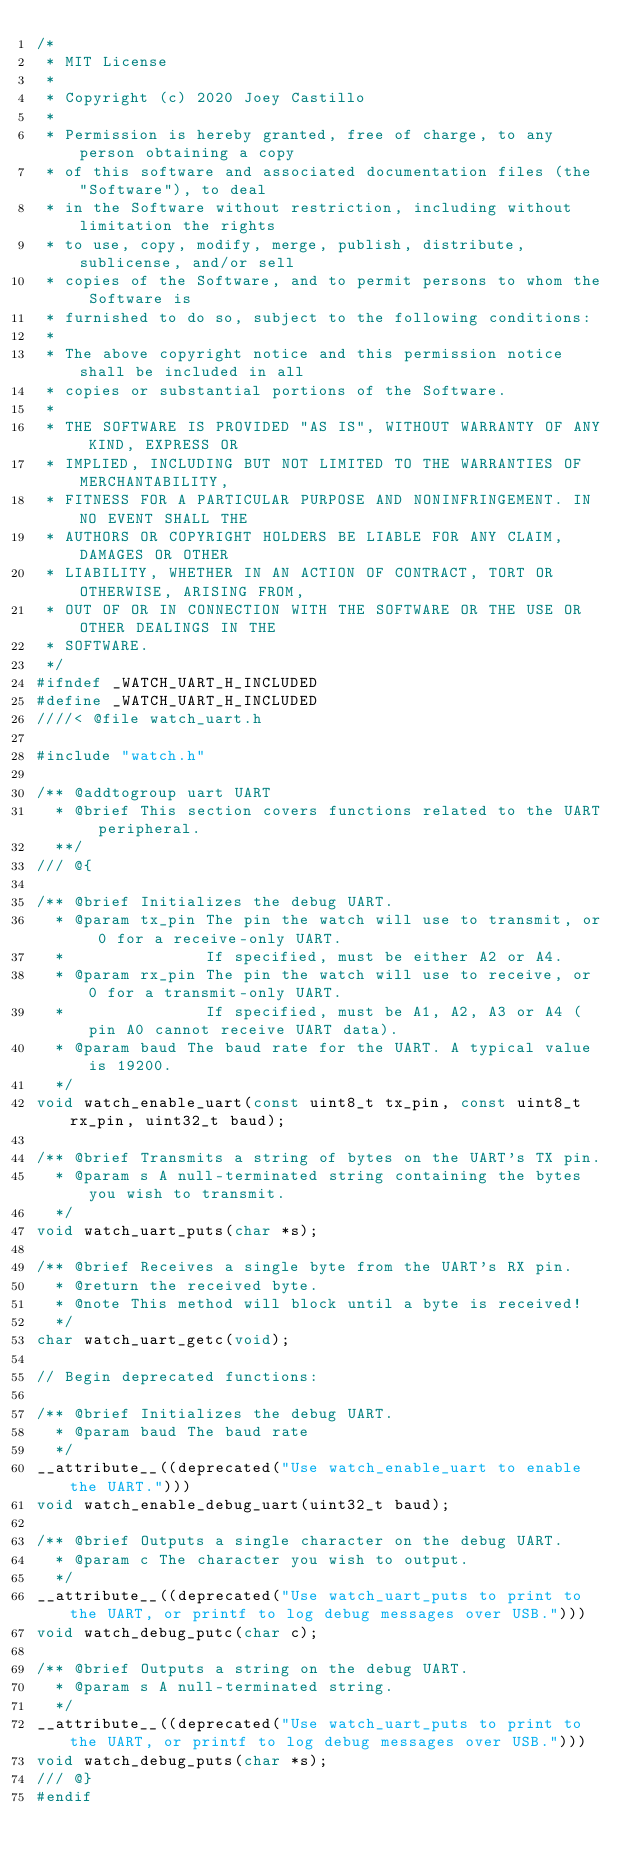Convert code to text. <code><loc_0><loc_0><loc_500><loc_500><_C_>/*
 * MIT License
 *
 * Copyright (c) 2020 Joey Castillo
 *
 * Permission is hereby granted, free of charge, to any person obtaining a copy
 * of this software and associated documentation files (the "Software"), to deal
 * in the Software without restriction, including without limitation the rights
 * to use, copy, modify, merge, publish, distribute, sublicense, and/or sell
 * copies of the Software, and to permit persons to whom the Software is
 * furnished to do so, subject to the following conditions:
 *
 * The above copyright notice and this permission notice shall be included in all
 * copies or substantial portions of the Software.
 *
 * THE SOFTWARE IS PROVIDED "AS IS", WITHOUT WARRANTY OF ANY KIND, EXPRESS OR
 * IMPLIED, INCLUDING BUT NOT LIMITED TO THE WARRANTIES OF MERCHANTABILITY,
 * FITNESS FOR A PARTICULAR PURPOSE AND NONINFRINGEMENT. IN NO EVENT SHALL THE
 * AUTHORS OR COPYRIGHT HOLDERS BE LIABLE FOR ANY CLAIM, DAMAGES OR OTHER
 * LIABILITY, WHETHER IN AN ACTION OF CONTRACT, TORT OR OTHERWISE, ARISING FROM,
 * OUT OF OR IN CONNECTION WITH THE SOFTWARE OR THE USE OR OTHER DEALINGS IN THE
 * SOFTWARE.
 */
#ifndef _WATCH_UART_H_INCLUDED
#define _WATCH_UART_H_INCLUDED
////< @file watch_uart.h

#include "watch.h"

/** @addtogroup uart UART
  * @brief This section covers functions related to the UART peripheral.
  **/
/// @{

/** @brief Initializes the debug UART.
  * @param tx_pin The pin the watch will use to transmit, or 0 for a receive-only UART.
  *               If specified, must be either A2 or A4.
  * @param rx_pin The pin the watch will use to receive, or 0 for a transmit-only UART.
  *               If specified, must be A1, A2, A3 or A4 (pin A0 cannot receive UART data).
  * @param baud The baud rate for the UART. A typical value is 19200.
  */
void watch_enable_uart(const uint8_t tx_pin, const uint8_t rx_pin, uint32_t baud);

/** @brief Transmits a string of bytes on the UART's TX pin.
  * @param s A null-terminated string containing the bytes you wish to transmit.
  */
void watch_uart_puts(char *s);

/** @brief Receives a single byte from the UART's RX pin.
  * @return the received byte.
  * @note This method will block until a byte is received!
  */
char watch_uart_getc(void);

// Begin deprecated functions:

/** @brief Initializes the debug UART.
  * @param baud The baud rate
  */
__attribute__((deprecated("Use watch_enable_uart to enable the UART.")))
void watch_enable_debug_uart(uint32_t baud);

/** @brief Outputs a single character on the debug UART.
  * @param c The character you wish to output.
  */
__attribute__((deprecated("Use watch_uart_puts to print to the UART, or printf to log debug messages over USB.")))
void watch_debug_putc(char c);

/** @brief Outputs a string on the debug UART.
  * @param s A null-terminated string.
  */
__attribute__((deprecated("Use watch_uart_puts to print to the UART, or printf to log debug messages over USB.")))
void watch_debug_puts(char *s);
/// @}
#endif
</code> 